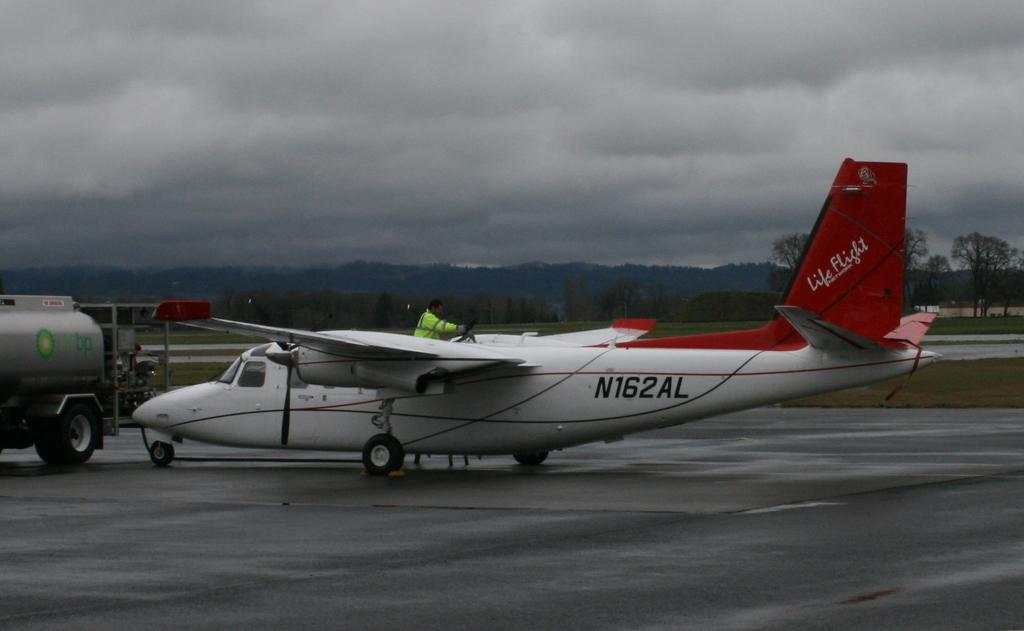<image>
Describe the image concisely. A red and white plane with the words Life Flight on the tail. 